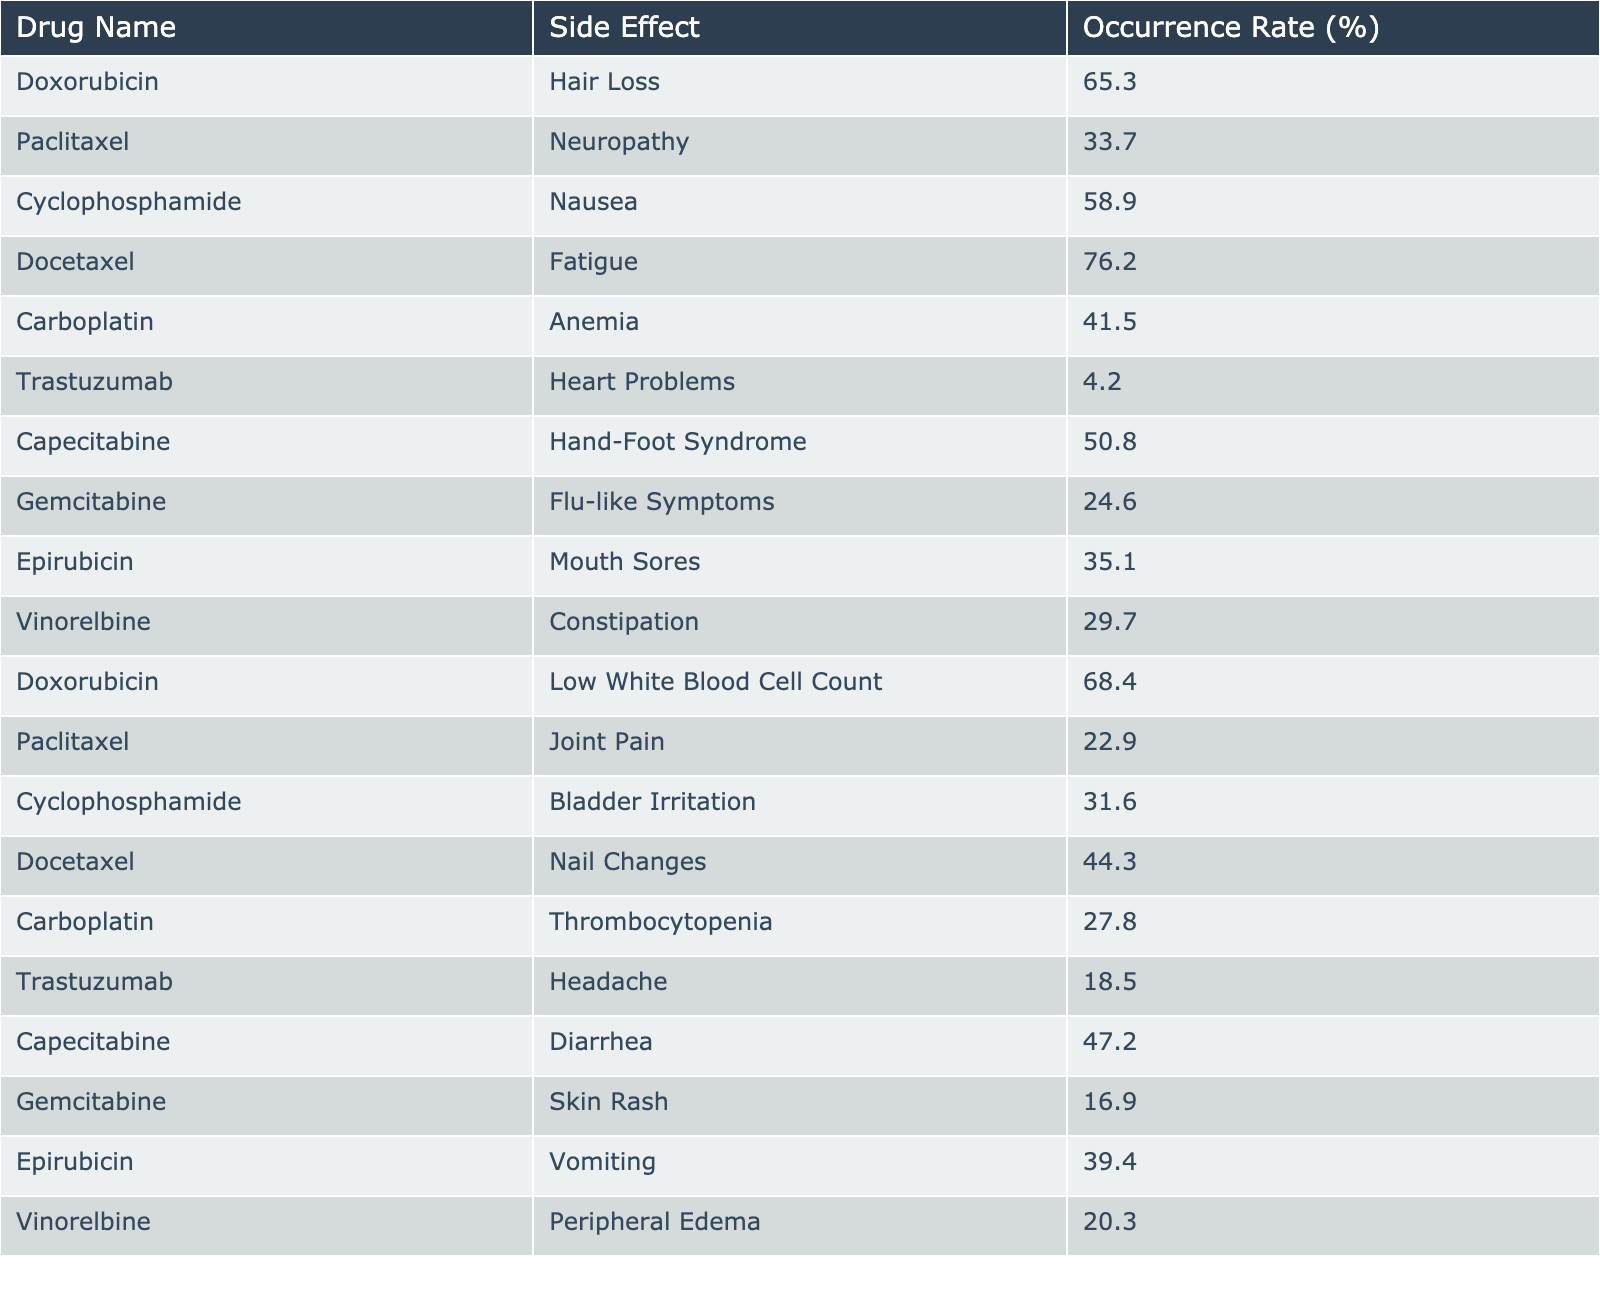What is the side effect with the highest occurrence rate? By scanning the table, we see that Docetaxel has the highest occurrence rate of 76.2% for fatigue.
Answer: Fatigue Which drug is associated with the side effect of neuropathy? The table shows that Paclitaxel is the drug that has neuropathy as a side effect, with an occurrence rate of 33.7%.
Answer: Paclitaxel How many drugs have an occurrence rate of 50% or higher? Looking through the table, we find the drugs with rates 65.3%, 58.9%, 76.2%, 50.8%, and 47.2%, meaning there are a total of 5 drugs.
Answer: 5 Is the occurrence rate of heart problems higher than 10%? The table indicates that Trastuzumab has an occurrence rate of 4.2% for heart problems, which is lower than 10%.
Answer: No What is the average occurrence rate of side effects for the drugs used in the table? We first sum all occurrence rates: 65.3 + 33.7 + 58.9 + 76.2 + 41.5 + 4.2 + 50.8 + 24.6 + 35.1 + 29.7 + 68.4 + 22.9 + 31.6 + 44.3 + 27.8 + 18.5 + 47.2 + 16.9 + 39.4 + 20.3 = 591.2. There are 20 drugs, so the average is 591.2 / 20 = 29.56.
Answer: 29.56 Which two side effects are associated with the drug Doxorubicin? By examining the table, we see that Doxorubicin is associated with hair loss (65.3%) and low white blood cell count (68.4%).
Answer: Hair Loss and Low White Blood Cell Count What is the difference in occurrence rates between the highest and lowest side effects in the table? The highest side effect occurrence is 76.2% (Docetaxel for fatigue) and the lowest is 4.2% (Trastuzumab for heart problems). The difference is 76.2 - 4.2 = 72%.
Answer: 72% Which side effect is most commonly associated with Cyclophosphamide? The table shows two side effects associated with Cyclophosphamide: nausea (58.9%) and bladder irritation (31.6%). The most common is nausea.
Answer: Nausea Are the occurrence rates for bowel-related side effects (nausea, diarrhea, constipation) above 30%? Nausea is 58.9%, diarrhea is 47.2%, and constipation is 29.7%. The rates for nausea and diarrhea are above 30% but constipation is not, thus not all are above 30%.
Answer: No What is the occurrence rate of any drug that causes hand-foot syndrome? Capecitabine is listed in the table with a hand-foot syndrome occurrence rate of 50.8%.
Answer: 50.8% 